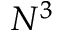Convert formula to latex. <formula><loc_0><loc_0><loc_500><loc_500>N ^ { 3 }</formula> 